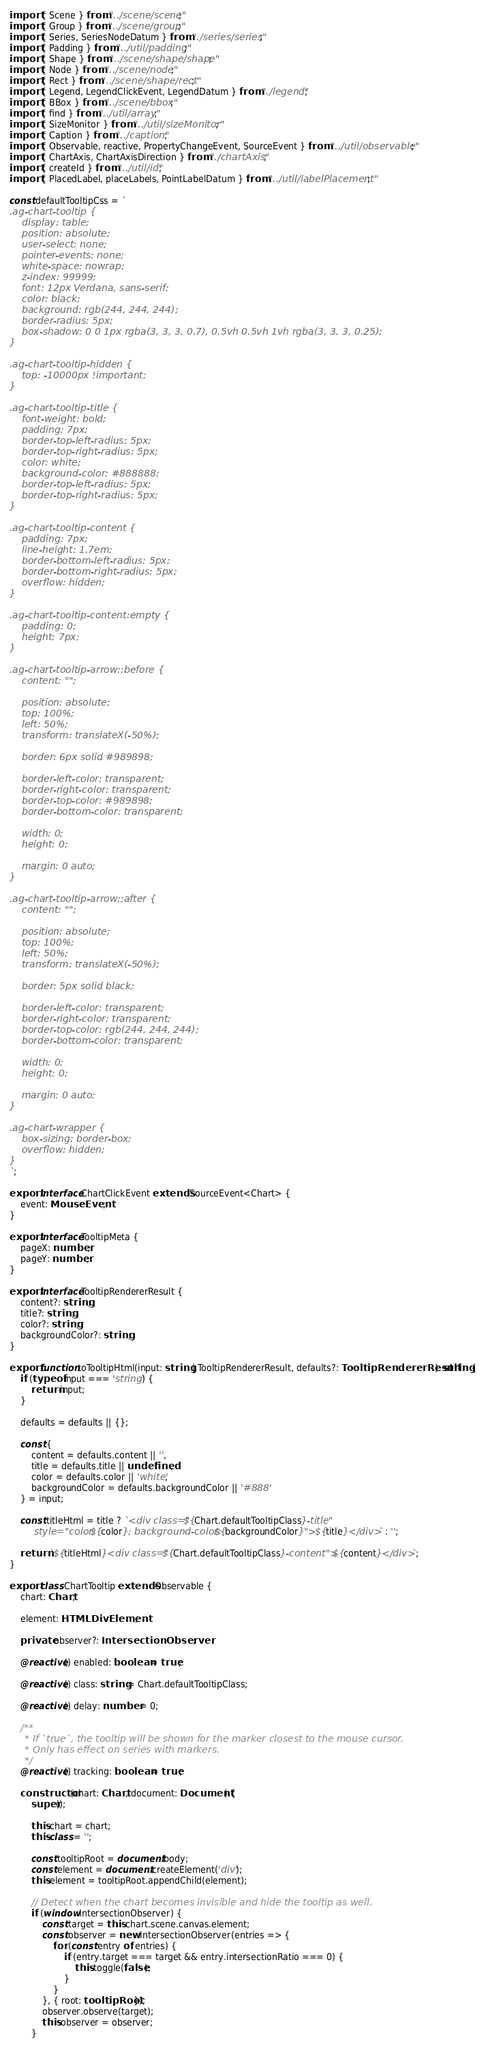Convert code to text. <code><loc_0><loc_0><loc_500><loc_500><_TypeScript_>import { Scene } from "../scene/scene";
import { Group } from "../scene/group";
import { Series, SeriesNodeDatum } from "./series/series";
import { Padding } from "../util/padding";
import { Shape } from "../scene/shape/shape";
import { Node } from "../scene/node";
import { Rect } from "../scene/shape/rect";
import { Legend, LegendClickEvent, LegendDatum } from "./legend";
import { BBox } from "../scene/bbox";
import { find } from "../util/array";
import { SizeMonitor } from "../util/sizeMonitor";
import { Caption } from "../caption";
import { Observable, reactive, PropertyChangeEvent, SourceEvent } from "../util/observable";
import { ChartAxis, ChartAxisDirection } from "./chartAxis";
import { createId } from "../util/id";
import { PlacedLabel, placeLabels, PointLabelDatum } from "../util/labelPlacement";

const defaultTooltipCss = `
.ag-chart-tooltip {
    display: table;
    position: absolute;
    user-select: none;
    pointer-events: none;
    white-space: nowrap;
    z-index: 99999;
    font: 12px Verdana, sans-serif;
    color: black;
    background: rgb(244, 244, 244);
    border-radius: 5px;
    box-shadow: 0 0 1px rgba(3, 3, 3, 0.7), 0.5vh 0.5vh 1vh rgba(3, 3, 3, 0.25);
}

.ag-chart-tooltip-hidden {
    top: -10000px !important;
}

.ag-chart-tooltip-title {
    font-weight: bold;
    padding: 7px;
    border-top-left-radius: 5px;
    border-top-right-radius: 5px;
    color: white;
    background-color: #888888;
    border-top-left-radius: 5px;
    border-top-right-radius: 5px;
}

.ag-chart-tooltip-content {
    padding: 7px;
    line-height: 1.7em;
    border-bottom-left-radius: 5px;
    border-bottom-right-radius: 5px;
    overflow: hidden;
}

.ag-chart-tooltip-content:empty {
    padding: 0;
    height: 7px;
}

.ag-chart-tooltip-arrow::before {
    content: "";

    position: absolute;
    top: 100%;
    left: 50%;
    transform: translateX(-50%);

    border: 6px solid #989898;

    border-left-color: transparent;
    border-right-color: transparent;
    border-top-color: #989898;
    border-bottom-color: transparent;

    width: 0;
    height: 0;

    margin: 0 auto;
}

.ag-chart-tooltip-arrow::after {
    content: "";

    position: absolute;
    top: 100%;
    left: 50%;
    transform: translateX(-50%);

    border: 5px solid black;

    border-left-color: transparent;
    border-right-color: transparent;
    border-top-color: rgb(244, 244, 244);
    border-bottom-color: transparent;

    width: 0;
    height: 0;

    margin: 0 auto;
}

.ag-chart-wrapper {
    box-sizing: border-box;
    overflow: hidden;
}
`;

export interface ChartClickEvent extends SourceEvent<Chart> {
    event: MouseEvent;
}

export interface TooltipMeta {
    pageX: number;
    pageY: number;
}

export interface TooltipRendererResult {
    content?: string;
    title?: string;
    color?: string;
    backgroundColor?: string;
}

export function toTooltipHtml(input: string | TooltipRendererResult, defaults?: TooltipRendererResult): string {
    if (typeof input === 'string') {
        return input;
    }

    defaults = defaults || {};

    const {
        content = defaults.content || '',
        title = defaults.title || undefined,
        color = defaults.color || 'white',
        backgroundColor = defaults.backgroundColor || '#888'
    } = input;

    const titleHtml = title ? `<div class="${Chart.defaultTooltipClass}-title"
        style="color: ${color}; background-color: ${backgroundColor}">${title}</div>` : '';

    return `${titleHtml}<div class="${Chart.defaultTooltipClass}-content">${content}</div>`;
}

export class ChartTooltip extends Observable {
    chart: Chart;

    element: HTMLDivElement;

    private observer?: IntersectionObserver;

    @reactive() enabled: boolean = true;

    @reactive() class: string = Chart.defaultTooltipClass;

    @reactive() delay: number = 0;

    /**
     * If `true`, the tooltip will be shown for the marker closest to the mouse cursor.
     * Only has effect on series with markers.
     */
    @reactive() tracking: boolean = true;

    constructor(chart: Chart, document: Document) {
        super();

        this.chart = chart;
        this.class = '';

        const tooltipRoot = document.body;
        const element = document.createElement('div');
        this.element = tooltipRoot.appendChild(element);

        // Detect when the chart becomes invisible and hide the tooltip as well.
        if (window.IntersectionObserver) {
            const target = this.chart.scene.canvas.element;
            const observer = new IntersectionObserver(entries => {
                for (const entry of entries) {
                    if (entry.target === target && entry.intersectionRatio === 0) {
                        this.toggle(false);
                    }
                }
            }, { root: tooltipRoot });
            observer.observe(target);
            this.observer = observer;
        }</code> 